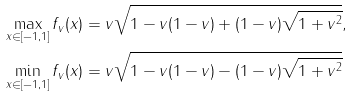Convert formula to latex. <formula><loc_0><loc_0><loc_500><loc_500>\max _ { x \in [ - 1 , 1 ] } f _ { v } ( x ) & = v \sqrt { 1 - v ( 1 - v ) + ( 1 - v ) \sqrt { 1 + v ^ { 2 } } } , \\ \min _ { x \in [ - 1 , 1 ] } f _ { v } ( x ) & = v \sqrt { 1 - v ( 1 - v ) - ( 1 - v ) \sqrt { 1 + v ^ { 2 } } }</formula> 